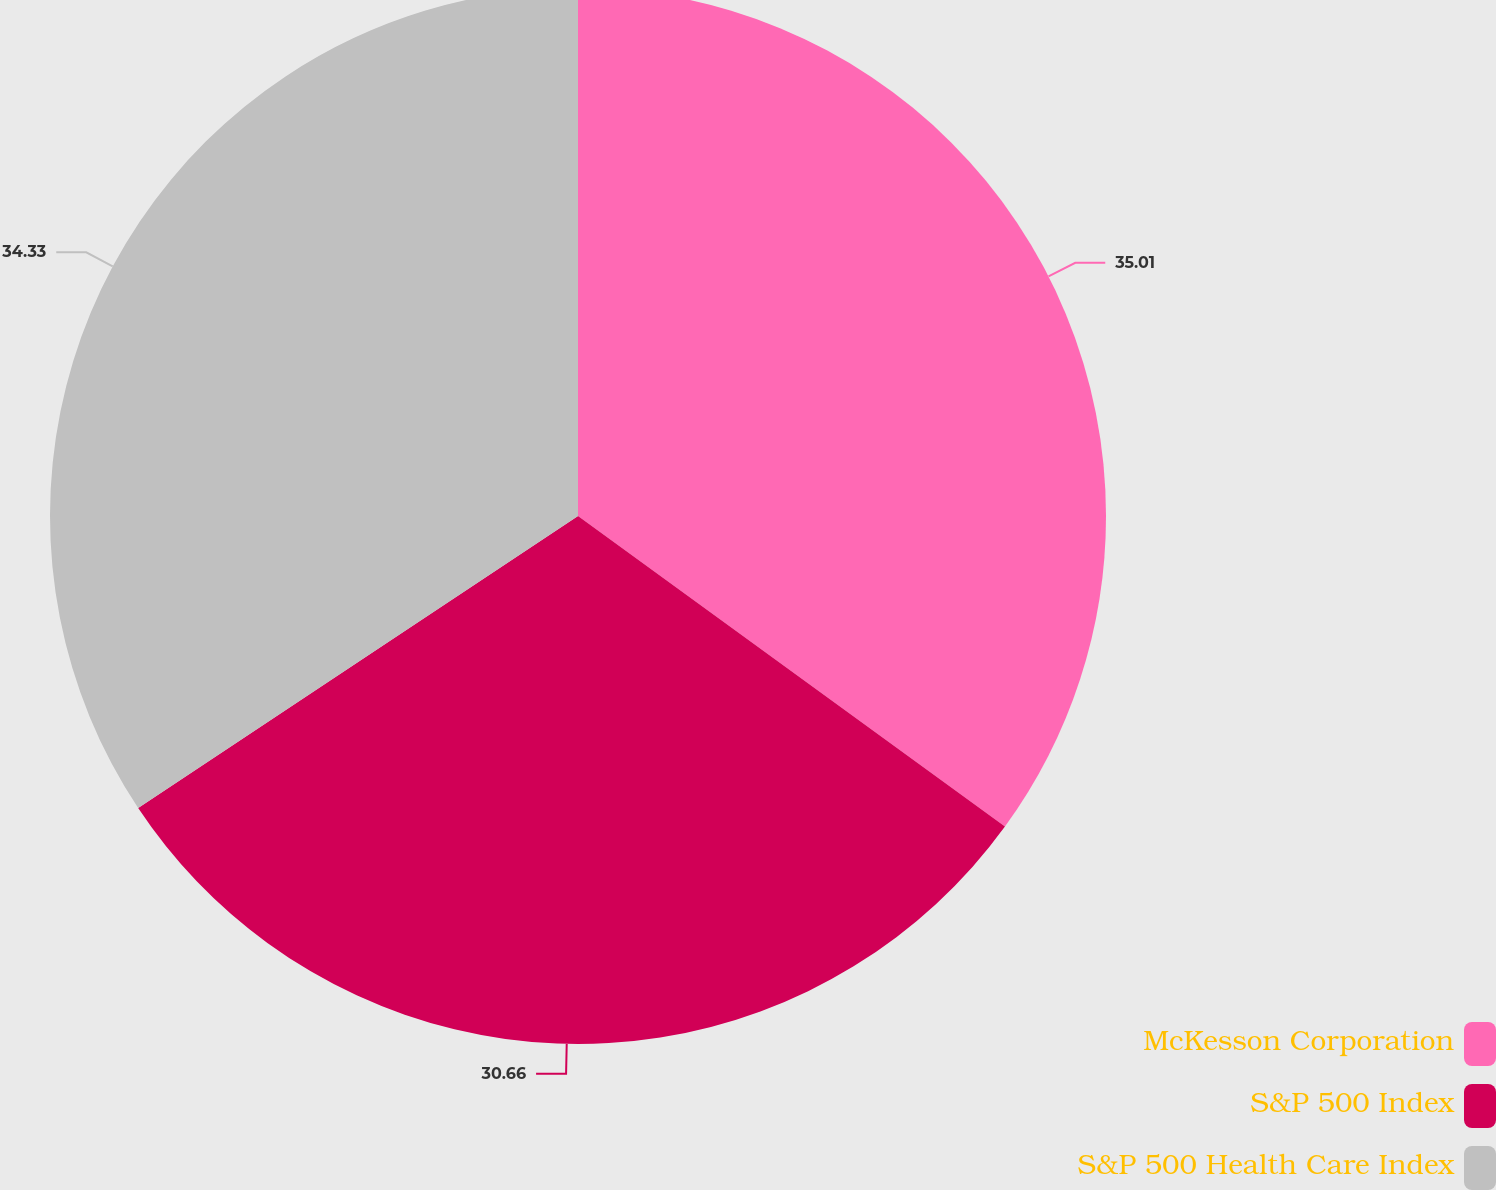Convert chart to OTSL. <chart><loc_0><loc_0><loc_500><loc_500><pie_chart><fcel>McKesson Corporation<fcel>S&P 500 Index<fcel>S&P 500 Health Care Index<nl><fcel>35.01%<fcel>30.66%<fcel>34.33%<nl></chart> 